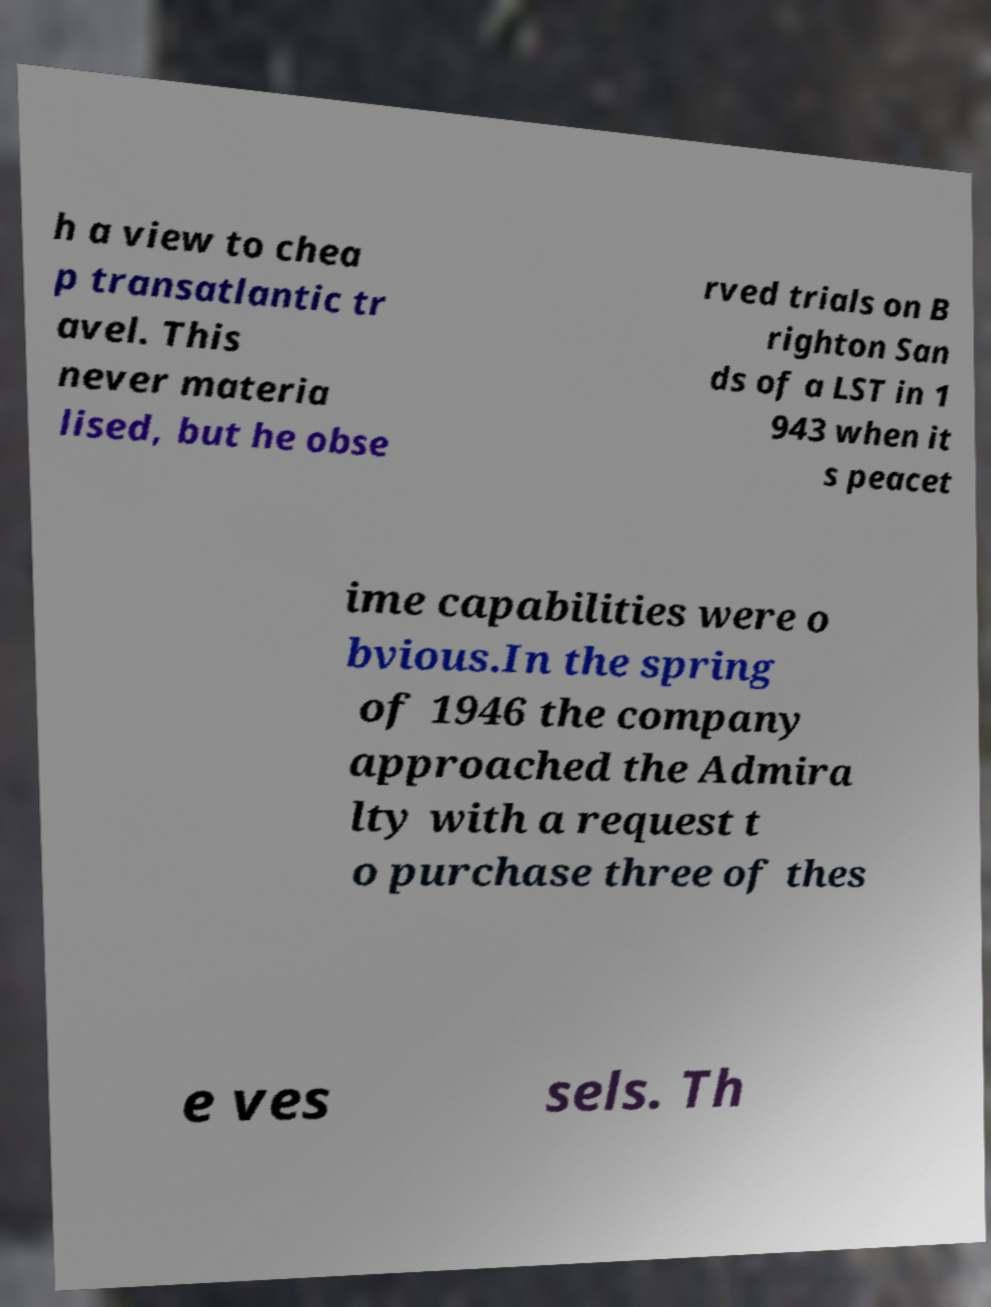I need the written content from this picture converted into text. Can you do that? h a view to chea p transatlantic tr avel. This never materia lised, but he obse rved trials on B righton San ds of a LST in 1 943 when it s peacet ime capabilities were o bvious.In the spring of 1946 the company approached the Admira lty with a request t o purchase three of thes e ves sels. Th 